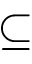Convert formula to latex. <formula><loc_0><loc_0><loc_500><loc_500>\subseteq</formula> 